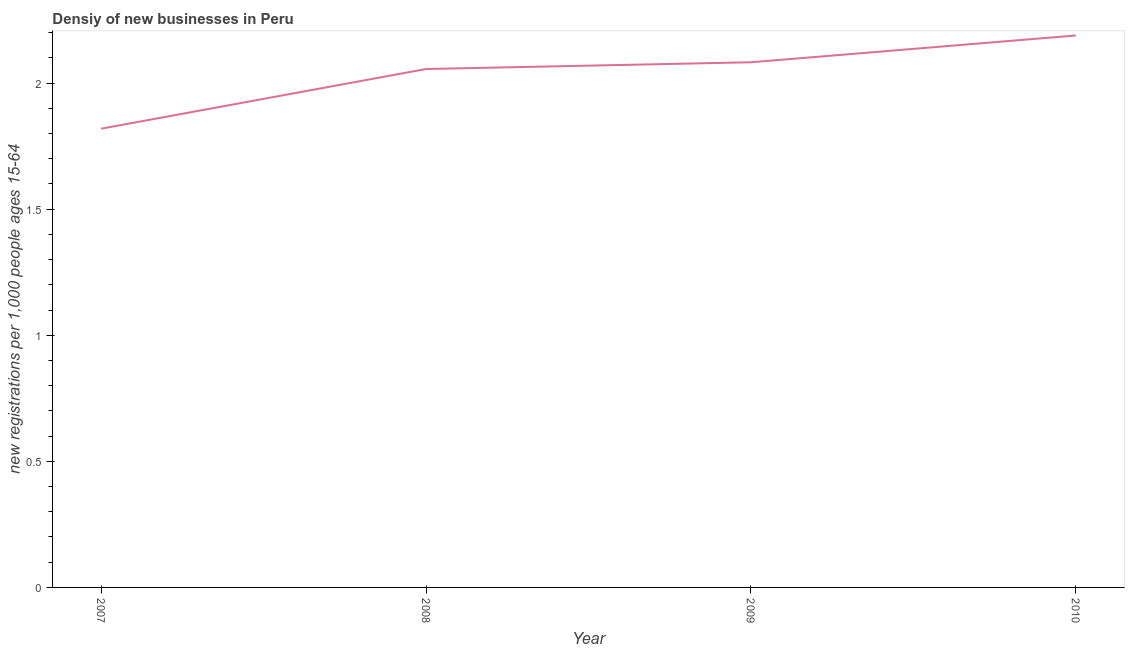What is the density of new business in 2009?
Your answer should be very brief. 2.08. Across all years, what is the maximum density of new business?
Your answer should be very brief. 2.19. Across all years, what is the minimum density of new business?
Offer a very short reply. 1.82. In which year was the density of new business maximum?
Provide a short and direct response. 2010. What is the sum of the density of new business?
Provide a succinct answer. 8.15. What is the difference between the density of new business in 2007 and 2009?
Offer a very short reply. -0.26. What is the average density of new business per year?
Offer a terse response. 2.04. What is the median density of new business?
Give a very brief answer. 2.07. Do a majority of the years between 2007 and 2008 (inclusive) have density of new business greater than 0.4 ?
Keep it short and to the point. Yes. What is the ratio of the density of new business in 2007 to that in 2009?
Your answer should be compact. 0.87. Is the difference between the density of new business in 2007 and 2009 greater than the difference between any two years?
Give a very brief answer. No. What is the difference between the highest and the second highest density of new business?
Your response must be concise. 0.11. What is the difference between the highest and the lowest density of new business?
Offer a terse response. 0.37. In how many years, is the density of new business greater than the average density of new business taken over all years?
Make the answer very short. 3. Does the graph contain grids?
Give a very brief answer. No. What is the title of the graph?
Your response must be concise. Densiy of new businesses in Peru. What is the label or title of the Y-axis?
Give a very brief answer. New registrations per 1,0 people ages 15-64. What is the new registrations per 1,000 people ages 15-64 in 2007?
Your answer should be very brief. 1.82. What is the new registrations per 1,000 people ages 15-64 in 2008?
Provide a short and direct response. 2.06. What is the new registrations per 1,000 people ages 15-64 in 2009?
Give a very brief answer. 2.08. What is the new registrations per 1,000 people ages 15-64 in 2010?
Give a very brief answer. 2.19. What is the difference between the new registrations per 1,000 people ages 15-64 in 2007 and 2008?
Ensure brevity in your answer.  -0.24. What is the difference between the new registrations per 1,000 people ages 15-64 in 2007 and 2009?
Offer a very short reply. -0.26. What is the difference between the new registrations per 1,000 people ages 15-64 in 2007 and 2010?
Your answer should be very brief. -0.37. What is the difference between the new registrations per 1,000 people ages 15-64 in 2008 and 2009?
Ensure brevity in your answer.  -0.03. What is the difference between the new registrations per 1,000 people ages 15-64 in 2008 and 2010?
Provide a short and direct response. -0.13. What is the difference between the new registrations per 1,000 people ages 15-64 in 2009 and 2010?
Offer a terse response. -0.11. What is the ratio of the new registrations per 1,000 people ages 15-64 in 2007 to that in 2008?
Your answer should be very brief. 0.89. What is the ratio of the new registrations per 1,000 people ages 15-64 in 2007 to that in 2009?
Offer a very short reply. 0.87. What is the ratio of the new registrations per 1,000 people ages 15-64 in 2007 to that in 2010?
Provide a short and direct response. 0.83. What is the ratio of the new registrations per 1,000 people ages 15-64 in 2008 to that in 2009?
Ensure brevity in your answer.  0.99. What is the ratio of the new registrations per 1,000 people ages 15-64 in 2008 to that in 2010?
Make the answer very short. 0.94. What is the ratio of the new registrations per 1,000 people ages 15-64 in 2009 to that in 2010?
Your answer should be very brief. 0.95. 